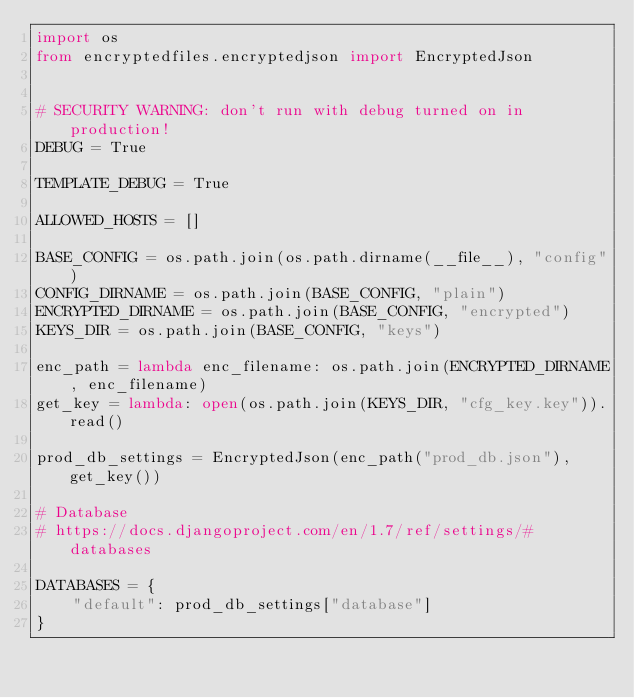<code> <loc_0><loc_0><loc_500><loc_500><_Python_>import os
from encryptedfiles.encryptedjson import EncryptedJson


# SECURITY WARNING: don't run with debug turned on in production!
DEBUG = True

TEMPLATE_DEBUG = True

ALLOWED_HOSTS = []

BASE_CONFIG = os.path.join(os.path.dirname(__file__), "config")
CONFIG_DIRNAME = os.path.join(BASE_CONFIG, "plain")
ENCRYPTED_DIRNAME = os.path.join(BASE_CONFIG, "encrypted")
KEYS_DIR = os.path.join(BASE_CONFIG, "keys")

enc_path = lambda enc_filename: os.path.join(ENCRYPTED_DIRNAME, enc_filename)
get_key = lambda: open(os.path.join(KEYS_DIR, "cfg_key.key")).read()

prod_db_settings = EncryptedJson(enc_path("prod_db.json"), get_key())

# Database
# https://docs.djangoproject.com/en/1.7/ref/settings/#databases

DATABASES = {
    "default": prod_db_settings["database"]
}</code> 